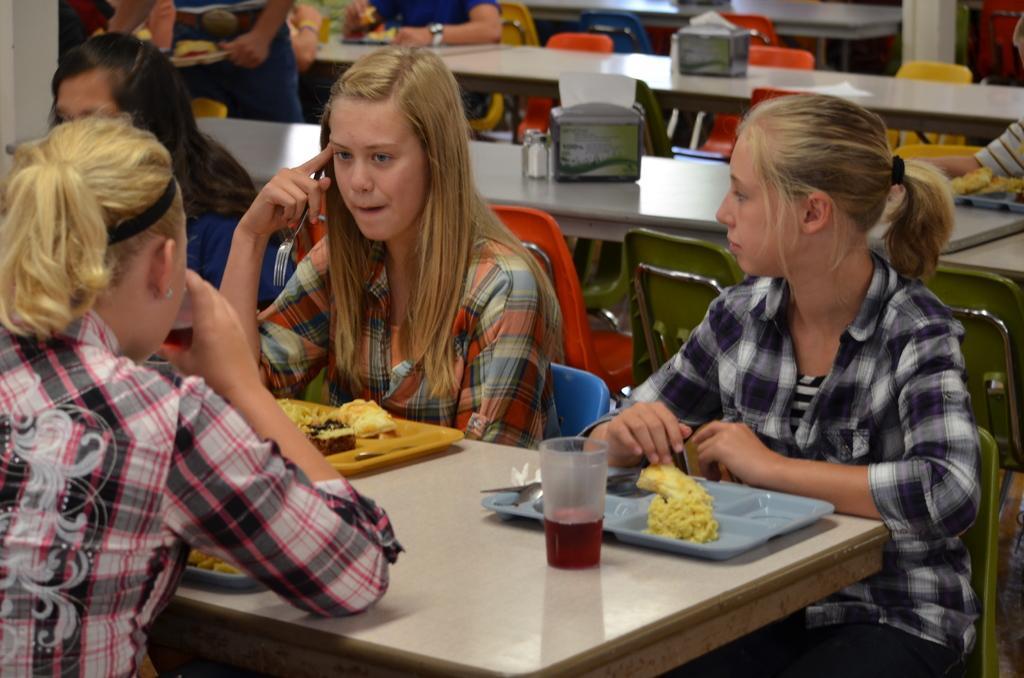Please provide a concise description of this image. As we can see in the image there are few people sitting on chairs and there are tables. On table there is a glass and plates. 